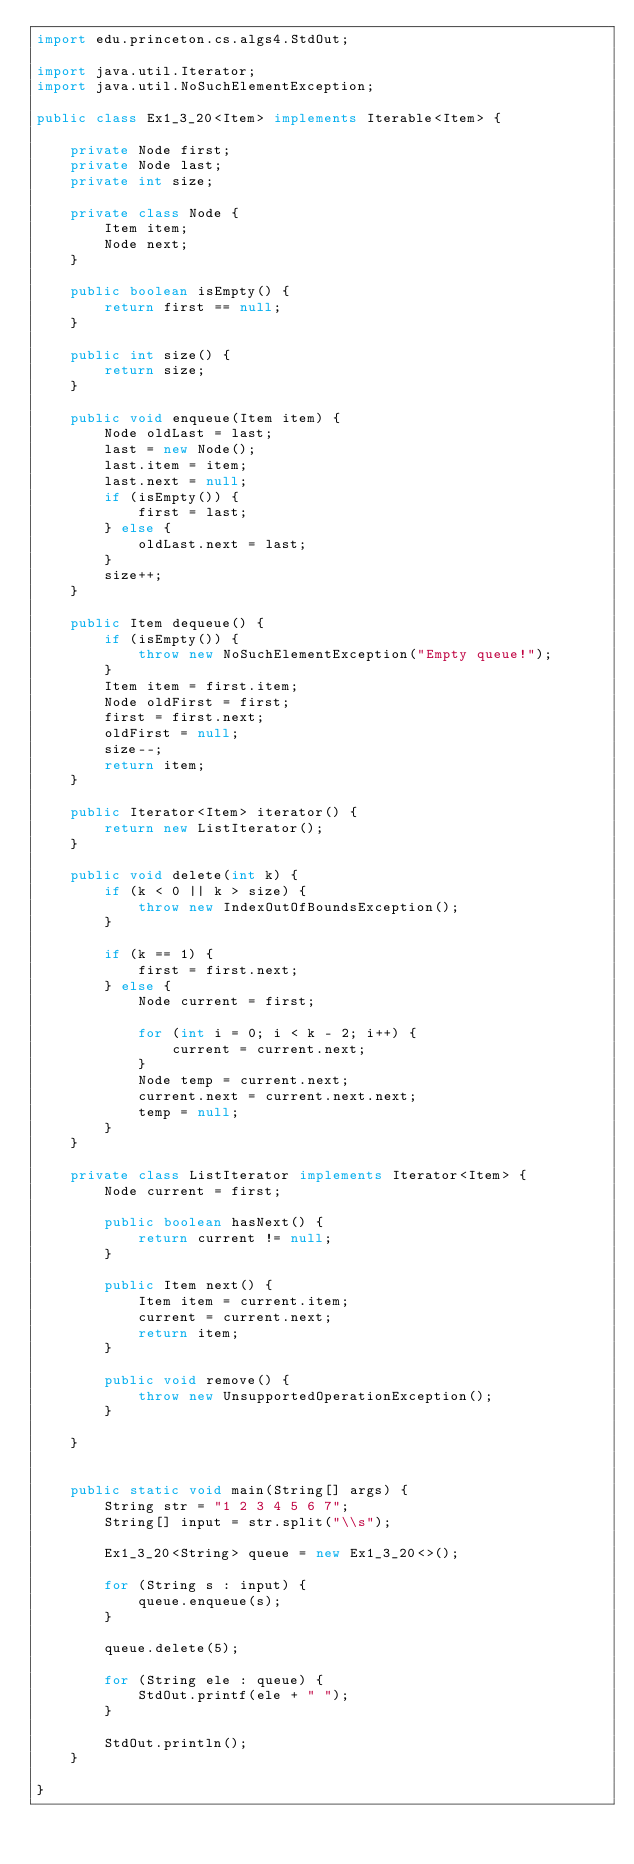<code> <loc_0><loc_0><loc_500><loc_500><_Java_>import edu.princeton.cs.algs4.StdOut;

import java.util.Iterator;
import java.util.NoSuchElementException;

public class Ex1_3_20<Item> implements Iterable<Item> {

    private Node first;
    private Node last;
    private int size;

    private class Node {
        Item item;
        Node next;
    }

    public boolean isEmpty() {
        return first == null;
    }

    public int size() {
        return size;
    }

    public void enqueue(Item item) {
        Node oldLast = last;
        last = new Node();
        last.item = item;
        last.next = null;
        if (isEmpty()) {
            first = last;
        } else {
            oldLast.next = last;
        }
        size++;
    }

    public Item dequeue() {
        if (isEmpty()) {
            throw new NoSuchElementException("Empty queue!");
        }
        Item item = first.item;
        Node oldFirst = first;
        first = first.next;
        oldFirst = null;
        size--;
        return item;
    }

    public Iterator<Item> iterator() {
        return new ListIterator();
    }

    public void delete(int k) {
        if (k < 0 || k > size) {
            throw new IndexOutOfBoundsException();
        }

        if (k == 1) {
            first = first.next;
        } else {
            Node current = first;

            for (int i = 0; i < k - 2; i++) {
                current = current.next;
            }
            Node temp = current.next;
            current.next = current.next.next;
            temp = null;
        }
    }

    private class ListIterator implements Iterator<Item> {
        Node current = first;

        public boolean hasNext() {
            return current != null;
        }

        public Item next() {
            Item item = current.item;
            current = current.next;
            return item;
        }

        public void remove() {
            throw new UnsupportedOperationException();
        }

    }


    public static void main(String[] args) {
        String str = "1 2 3 4 5 6 7";
        String[] input = str.split("\\s");

        Ex1_3_20<String> queue = new Ex1_3_20<>();

        for (String s : input) {
            queue.enqueue(s);
        }

        queue.delete(5);

        for (String ele : queue) {
            StdOut.printf(ele + " ");
        }

        StdOut.println();
    }

}
</code> 